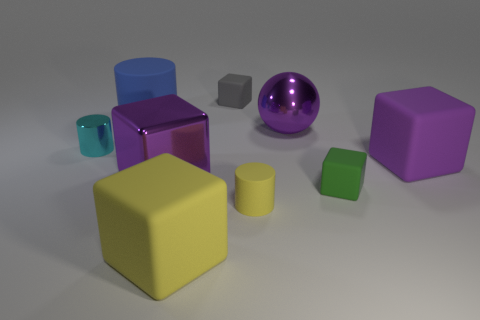Imagine if these objects were part of a children’s playground, how would you describe their potential uses? In a children's playground, these vibrant objects could serve as imaginative play equipment. The spheres could be envisioned as bouncy balls, the cubes as building blocks for fort construction, and the cylinders as tunnels or drums, encouraging creative play and interaction among children. 